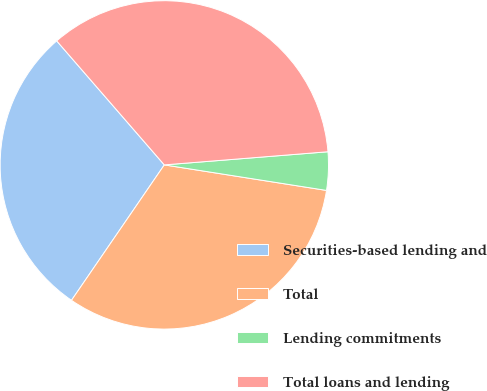<chart> <loc_0><loc_0><loc_500><loc_500><pie_chart><fcel>Securities-based lending and<fcel>Total<fcel>Lending commitments<fcel>Total loans and lending<nl><fcel>29.06%<fcel>32.08%<fcel>3.76%<fcel>35.1%<nl></chart> 